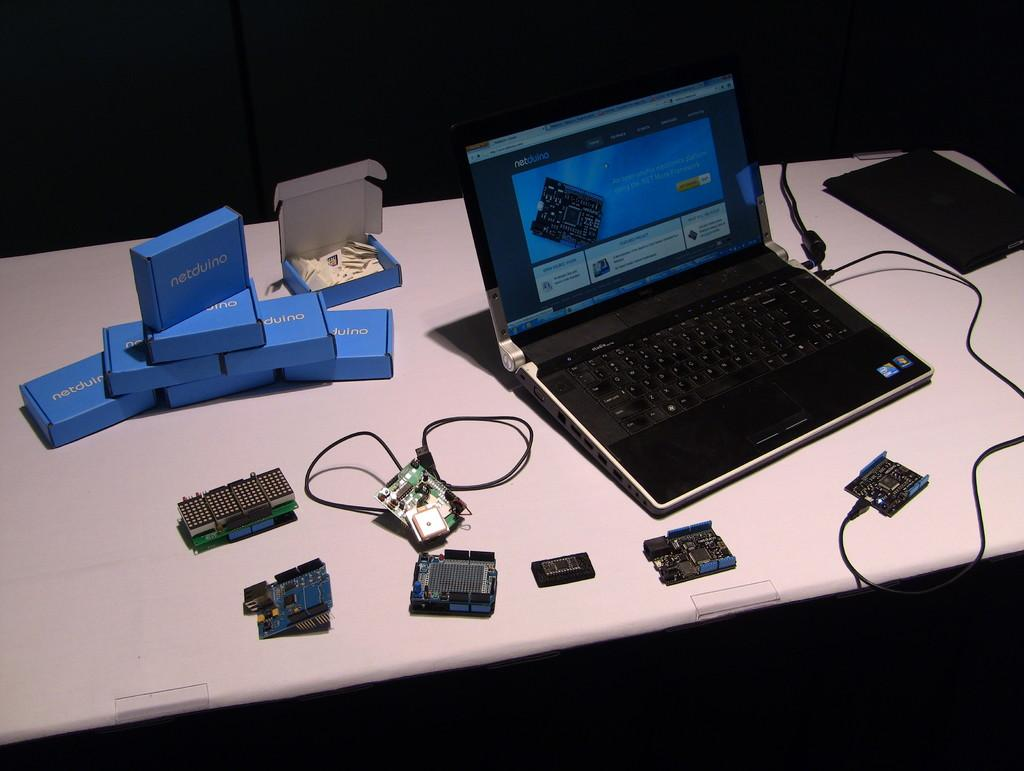Provide a one-sentence caption for the provided image. Netduino parts are sitting on a table with a laptop. 